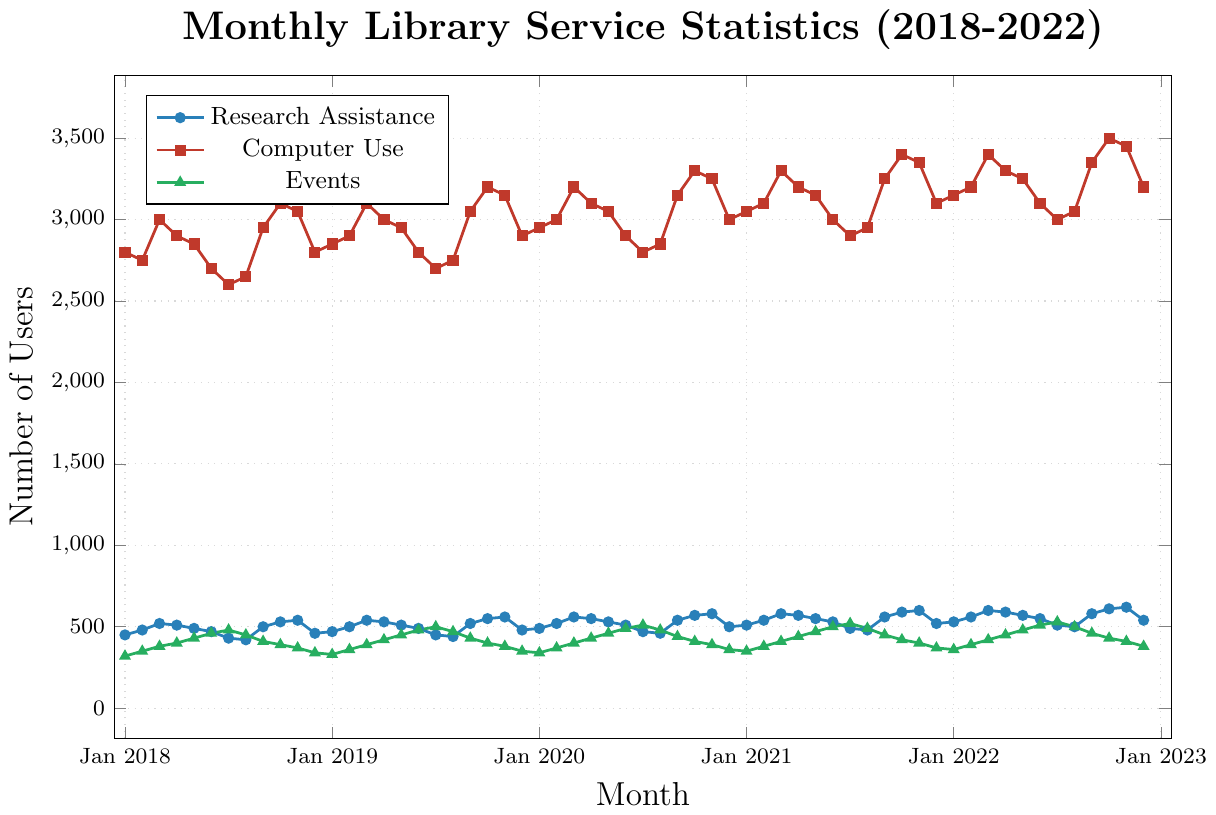What month has the highest number of users for Research Assistance? To determine the month with the highest number of users for Research Assistance, look for the peak point of the blue line in the chart. According to the data, the highest point is observed in Nov 2022 with 620 users.
Answer: Nov 2022 How does the number of users for Computer Use in Jan 2019 compare to Jan 2020? To compare the number of users for Computer Use, look at the red line's values for Jan 2019 and Jan 2020. In Jan 2019, the number of users is 2850, while in Jan 2020, it is 2950. Thus, Jan 2020 has 100 more users than Jan 2019.
Answer: Jan 2020 has 100 more users On average, how many people attended Events annually from 2018 to 2022? To calculate the average number of attendees per year, first determine the sum of monthly attendees for each year, then divide by 12. The results are: 2018: 4440, 2019: 4680, 2020: 5350, 2021: 5290, 2022: 5420. Average per year = (4440 + 4680 + 5350 + 5290 + 5420) / 5 = 5036.
Answer: 5036 Which service saw the most users in Dec 2022, and how many did it have? Check the highest values for each service in Dec 2022. The values are; Research Assistance: 540, Computer Use: 3200, Events: 380. Computer Use has the highest value.
Answer: Computer Use, 3200 Between 2020 and 2021, which service experienced the most significant increase in users between Jan and Dec? Calculate the difference between the users in Jan and Dec for each service for both years. For 2020: 
- Research Assistance: 500 - 490 = 10
- Computer Use: 3000 - 2950 = 50
- Events: 360 - 340 = 20
For 2021: 
- Research Assistance: 520 - 510 = 10
- Computer Use: 3100 - 3050 = 50
- Events: 370 - 350 = 20
The most significant increase for both years is in Computer Use, with a 50-user increase.
Answer: Computer Use What is the trend for Research Assistance users from Jul 2022 to Dec 2022? Observe the blue line from Jul 2022 to Dec 2022. The data shows 510, 500, 580, 610, 620, 540, indicating a general increasing trend with a small dip in Dec 2022.
Answer: Generally increasing In which months did Computer Use reach 3200 users or more? Check the red line for points reaching or exceeding 3200. The months are Oct 2019, Oct 2020, Mar 2021, Oct 2021, Mar 2022, Sep 2022, Oct 2022, and Nov 2022.
Answer: Oct 2019, Oct 2020, Mar 2021, Oct 2021, Mar 2022, Sep 2022, Oct 2022, Nov 2022 How does the pattern of Events attendance compare to Research Assistance in 2020? Compare the blue and green lines in 2020. The trend for Research Assistance is relatively stable, with a slight increase, while for Events, there is more variation with a peak around mid-year.
Answer: More stable for Research Assistance, more varied for Events What is the median number of Research Assistance users for all months in 2021? List all monthly user numbers for Research Assistance in 2021: 510, 540, 580, 570, 550, 530, 490, 480, 560, 590, 600, 520. The median is the middle value. Sorted: 480, 490, 510, 520, 530, 540, 550, 560, 570, 580, 590, 600. The middle values are 540 and 550; thus, the median is (540+550)/2 = 545.
Answer: 545 From Jan 2018 to Dec 2022, which service had the lowest recorded number of users in a single month, and what was that number? Look at the lowest points on each line. The lowest values are: Research Assistance: 420 (Aug 2018), Computer Use: 2600 (Jul 2018), Events: 320 (Jan 2018). The lowest recorded is 320 for Events in Jan 2018.
Answer: Events, 320 